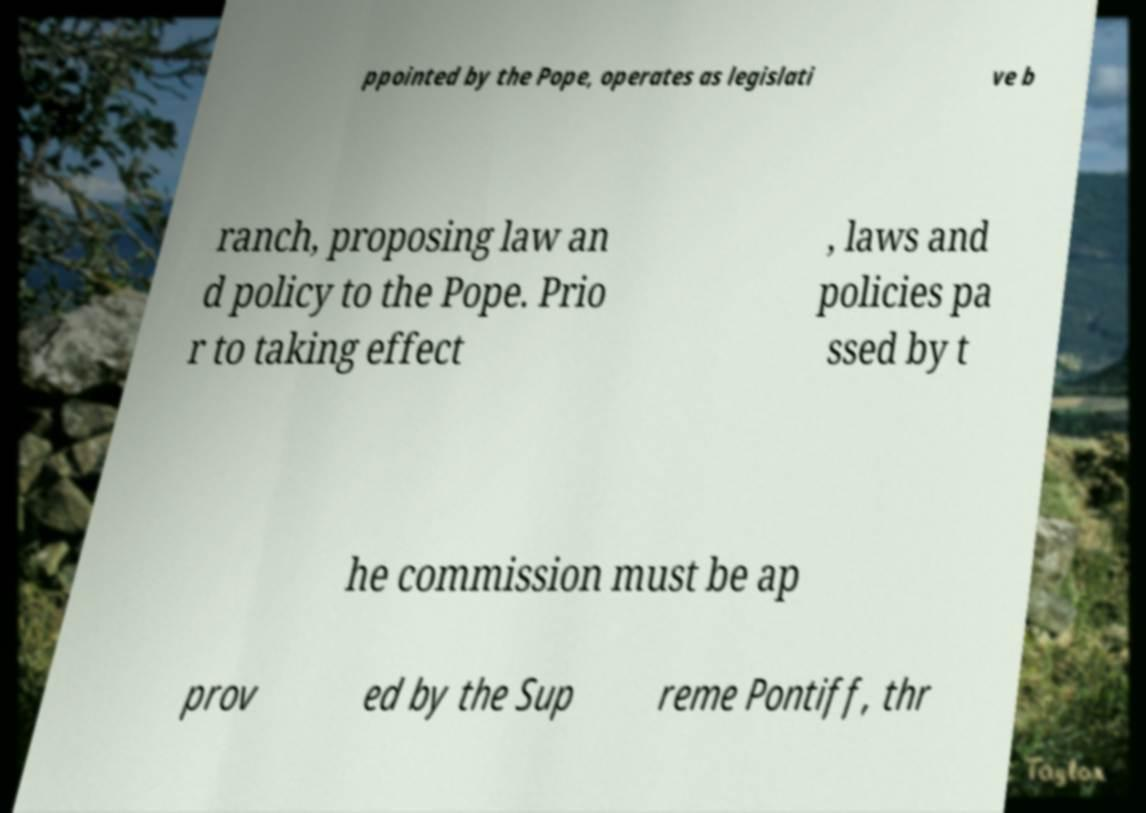Could you assist in decoding the text presented in this image and type it out clearly? ppointed by the Pope, operates as legislati ve b ranch, proposing law an d policy to the Pope. Prio r to taking effect , laws and policies pa ssed by t he commission must be ap prov ed by the Sup reme Pontiff, thr 